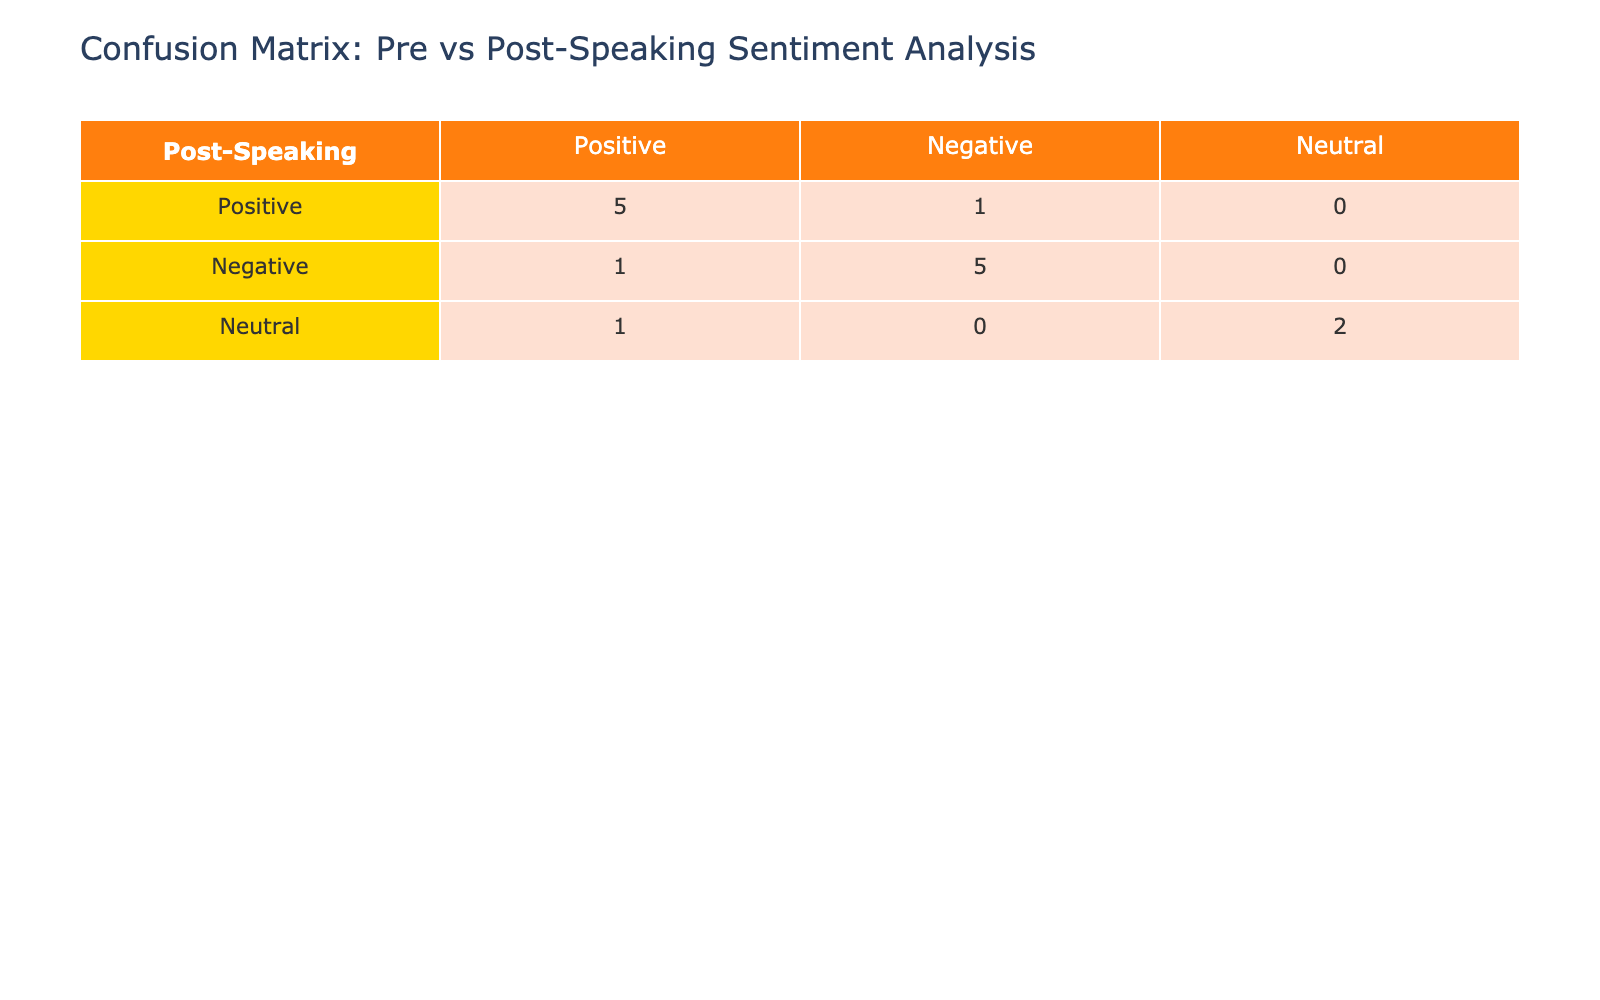What is the total number of positive sentiments predicted in the pre-speaking engagement? In the pre-speaking engagement, we look at the predictions under the "Positive" category. The counts for the predicted positive sentiments are the first row and the second row of the "Positive" column in the confusion matrix: Positive predicted as Positive counts as 5 and Positive predicted as Negative counts as 1. Therefore, we sum these counts: 5 (True Positives) + 1 (False Negatives) = 6.
Answer: 6 How many sentiments were predicted as positive after the speaking engagements? We check the predictions in the post-speaking engagement under the "Positive" category. The values in the "Positive" column include: Positive predicted as Positive (4), Negative predicted as Positive (2), and Neutral predicted as Positive (1). Summing these gives: 4 + 2 + 1 = 7.
Answer: 7 Is the predicted sentiment improved in the post-speaking engagement compared to the pre-speaking engagement? To determine if predictions improved, we compare the True Positives from both matrices. The pre-speaking engagement has 6 positives (5 TP + 1 FN), while the post-speaking engagement has 4 positives (4 TP). Since the number of accurately predicted positives decreased from pre to post, this indicates a decline, answering "No".
Answer: No What is the percentage of actual negative sentiments that were predicted as negative in the pre-speaking engagement? In the pre-speaking engagement, there are 5 actual negatives (the third row and the fifth row for "Negative"). Out of these, the predicted as Negative is 3. To find the percentage, we calculate: (3 / 5) * 100 = 60%.
Answer: 60% How many sentiments were classified as neutral in the pre-speaking engagement? We look at the "Neutral" category under the pre-speaking predictions. The "Neutral" predictions are listed: from the "Neutral" row, we count the predicted sentiments: 1 prediction as Neutral, and it’s also indicated in the other classifications. Summing these gives a total of 3.
Answer: 3 What is the total number of incorrect predictions (false positives and false negatives) for post-speaking engagement? We check the false predictions in the post-speaking confusion matrix. False positives are predictions of Negative counts under "Actual Positive" and identified as Negative which are 1. False negatives can be considered from "Actual Negative" as Positive counted under negative sentiment which is 2. Adding these together gives 1 (FP) + 2 (FN) = 3.
Answer: 3 What is the difference between the number of neutral sentiments predicted pre and post-speaking engagement? In the pre-speaking engagement, neutral predictions are 2 (under the "Neutral" column), and in the post speaking engagement, the neutral predictions are 1. The difference is calculated by subtracting post from pre: 2 - 1 = 1.
Answer: 1 